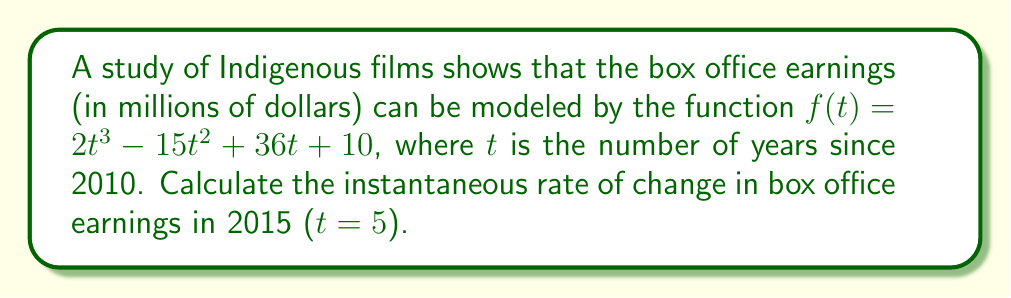What is the answer to this math problem? To find the instantaneous rate of change, we need to calculate the derivative of the function $f(t)$ and evaluate it at $t = 5$.

1) First, let's find the derivative of $f(t)$:
   $$f'(t) = \frac{d}{dt}(2t^3 - 15t^2 + 36t + 10)$$
   $$f'(t) = 6t^2 - 30t + 36$$

2) Now, we evaluate $f'(t)$ at $t = 5$:
   $$f'(5) = 6(5)^2 - 30(5) + 36$$
   $$f'(5) = 6(25) - 150 + 36$$
   $$f'(5) = 150 - 150 + 36$$
   $$f'(5) = 36$$

3) The units of the rate of change will be millions of dollars per year.

Therefore, the instantaneous rate of change in box office earnings for Indigenous films in 2015 is 36 million dollars per year.
Answer: $36$ million dollars per year 